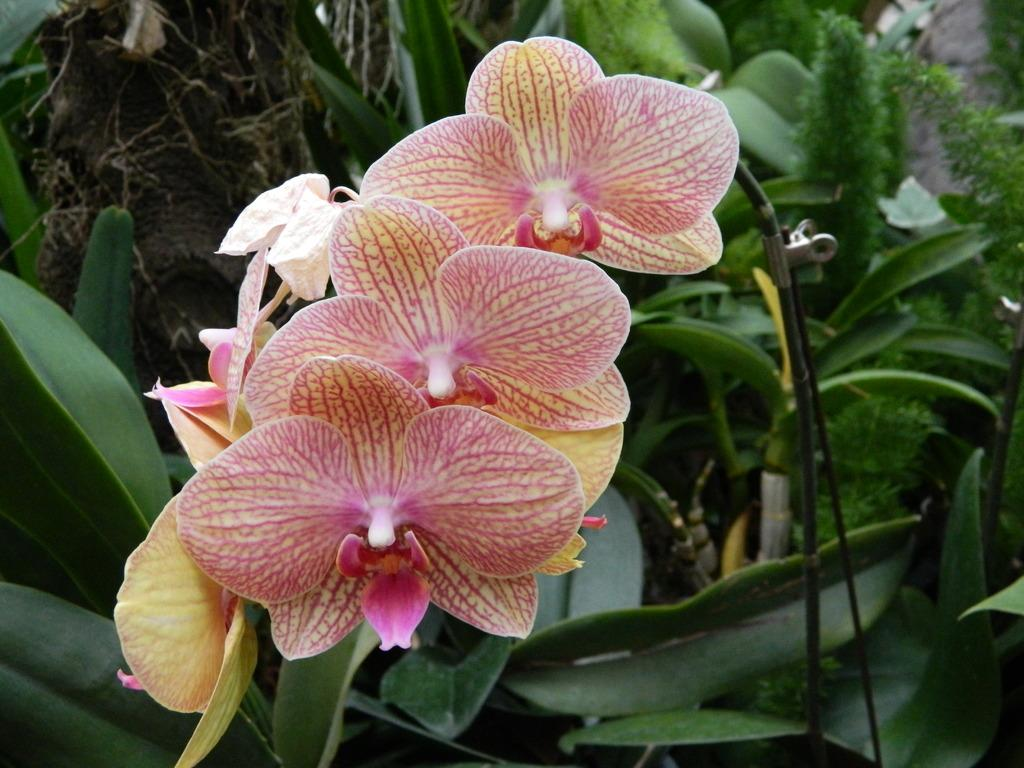What type of living organisms can be seen in the image? Plants and flowers are visible in the image. What color are the flowers in the image? The flowers in the image are pinkish in color. What color are the leaves in the image? The leaves in the image are green in color. Can you describe any other objects in the image? Yes, there appears to be a wire in the image. How does the coal contribute to the beauty of the image? There is no coal present in the image, so it does not contribute to the beauty of the image. 